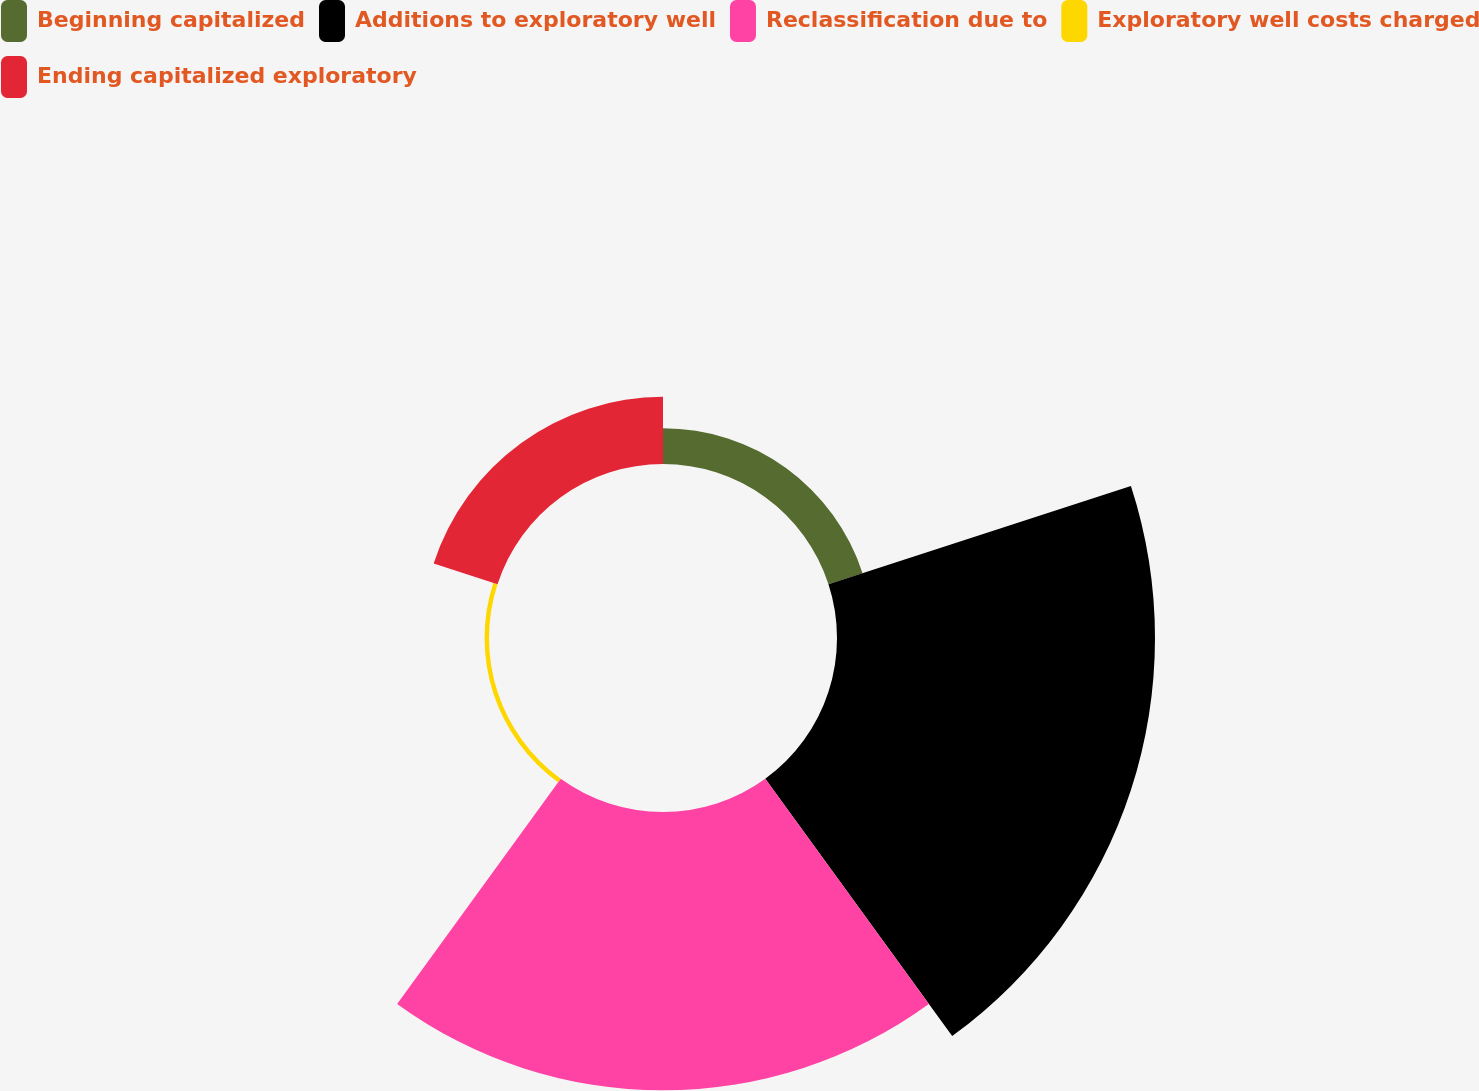Convert chart to OTSL. <chart><loc_0><loc_0><loc_500><loc_500><pie_chart><fcel>Beginning capitalized<fcel>Additions to exploratory well<fcel>Reclassification due to<fcel>Exploratory well costs charged<fcel>Ending capitalized exploratory<nl><fcel>5.09%<fcel>45.19%<fcel>39.55%<fcel>0.63%<fcel>9.54%<nl></chart> 